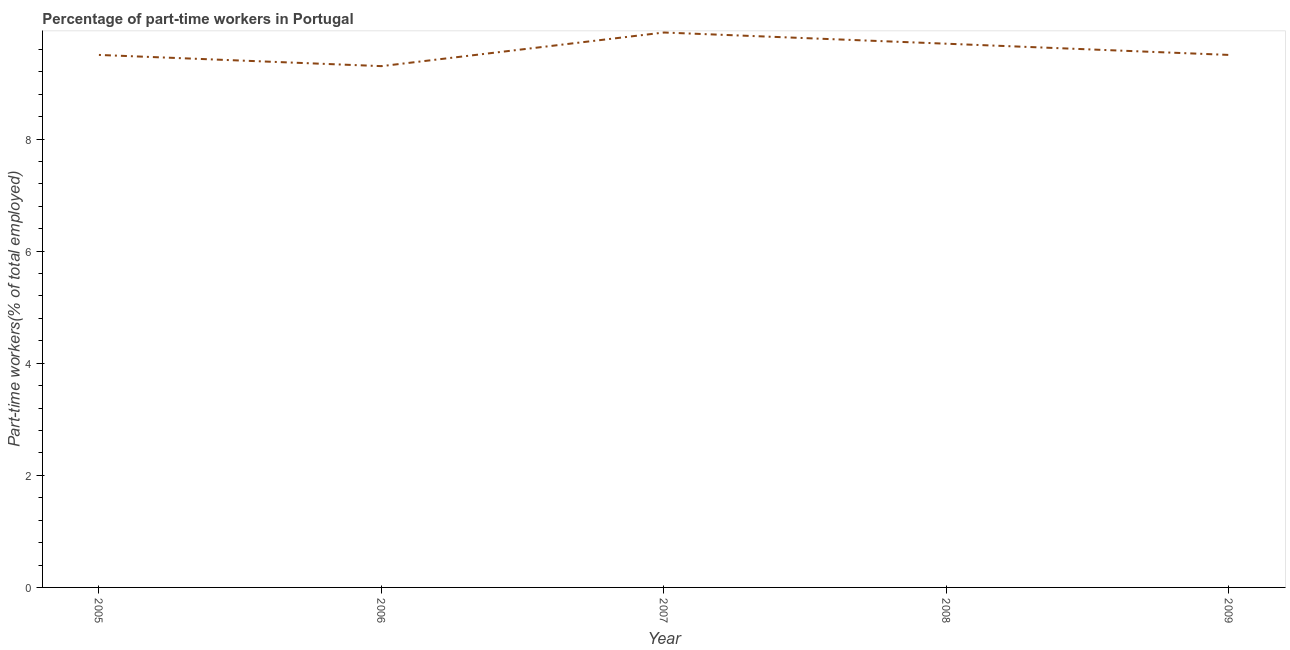What is the percentage of part-time workers in 2006?
Keep it short and to the point. 9.3. Across all years, what is the maximum percentage of part-time workers?
Keep it short and to the point. 9.9. Across all years, what is the minimum percentage of part-time workers?
Keep it short and to the point. 9.3. In which year was the percentage of part-time workers maximum?
Your answer should be compact. 2007. What is the sum of the percentage of part-time workers?
Provide a succinct answer. 47.9. What is the difference between the percentage of part-time workers in 2008 and 2009?
Keep it short and to the point. 0.2. What is the average percentage of part-time workers per year?
Your answer should be very brief. 9.58. In how many years, is the percentage of part-time workers greater than 2.4 %?
Offer a very short reply. 5. What is the ratio of the percentage of part-time workers in 2006 to that in 2008?
Ensure brevity in your answer.  0.96. What is the difference between the highest and the second highest percentage of part-time workers?
Ensure brevity in your answer.  0.2. What is the difference between the highest and the lowest percentage of part-time workers?
Your response must be concise. 0.6. Does the percentage of part-time workers monotonically increase over the years?
Keep it short and to the point. No. Does the graph contain any zero values?
Provide a short and direct response. No. What is the title of the graph?
Your response must be concise. Percentage of part-time workers in Portugal. What is the label or title of the X-axis?
Provide a short and direct response. Year. What is the label or title of the Y-axis?
Keep it short and to the point. Part-time workers(% of total employed). What is the Part-time workers(% of total employed) in 2005?
Your answer should be very brief. 9.5. What is the Part-time workers(% of total employed) in 2006?
Offer a terse response. 9.3. What is the Part-time workers(% of total employed) of 2007?
Provide a short and direct response. 9.9. What is the Part-time workers(% of total employed) of 2008?
Provide a succinct answer. 9.7. What is the difference between the Part-time workers(% of total employed) in 2005 and 2006?
Make the answer very short. 0.2. What is the difference between the Part-time workers(% of total employed) in 2005 and 2008?
Provide a succinct answer. -0.2. What is the difference between the Part-time workers(% of total employed) in 2005 and 2009?
Make the answer very short. 0. What is the difference between the Part-time workers(% of total employed) in 2006 and 2007?
Your answer should be compact. -0.6. What is the difference between the Part-time workers(% of total employed) in 2006 and 2009?
Your answer should be compact. -0.2. What is the difference between the Part-time workers(% of total employed) in 2007 and 2008?
Your answer should be very brief. 0.2. What is the difference between the Part-time workers(% of total employed) in 2007 and 2009?
Your answer should be compact. 0.4. What is the difference between the Part-time workers(% of total employed) in 2008 and 2009?
Give a very brief answer. 0.2. What is the ratio of the Part-time workers(% of total employed) in 2005 to that in 2006?
Your answer should be very brief. 1.02. What is the ratio of the Part-time workers(% of total employed) in 2006 to that in 2007?
Provide a succinct answer. 0.94. What is the ratio of the Part-time workers(% of total employed) in 2007 to that in 2008?
Your response must be concise. 1.02. What is the ratio of the Part-time workers(% of total employed) in 2007 to that in 2009?
Ensure brevity in your answer.  1.04. 